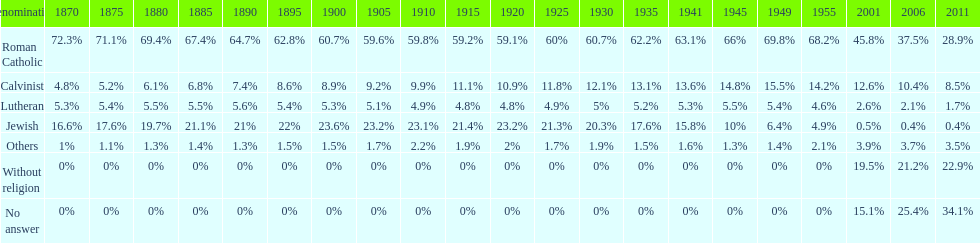How many sects never fell below 20%? 1. 